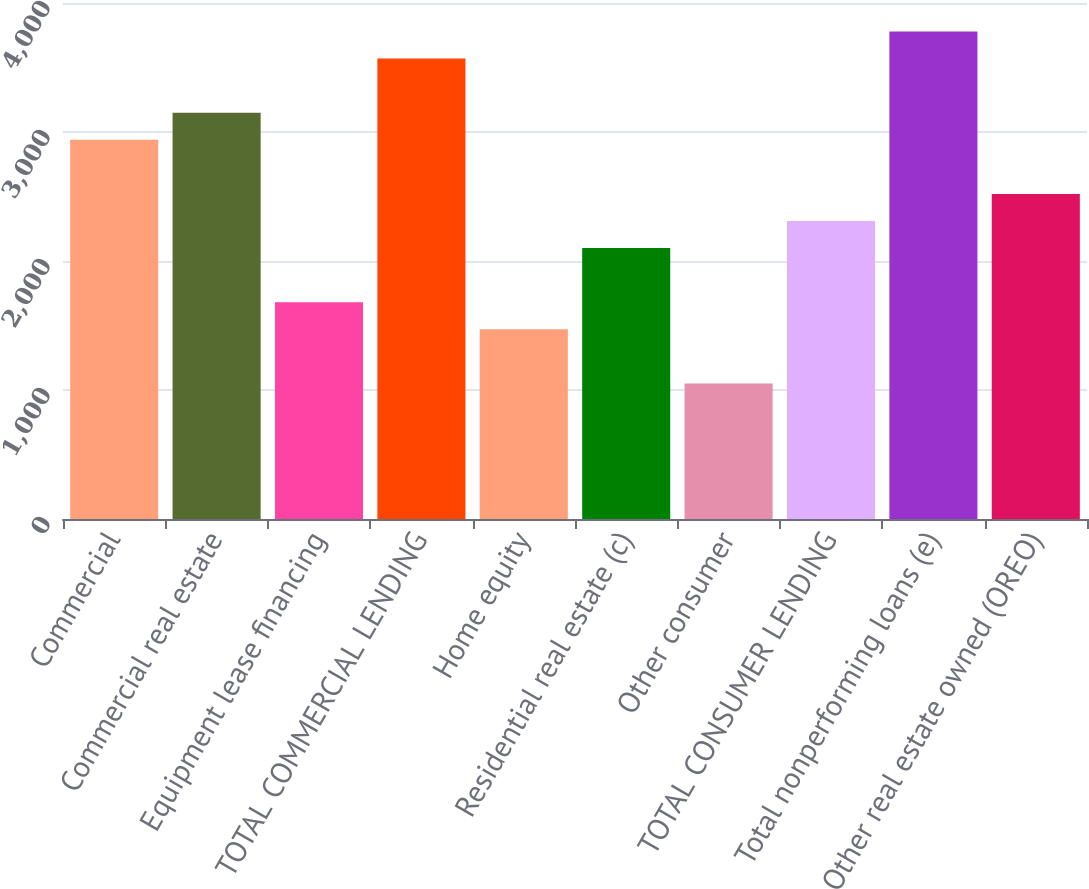Convert chart to OTSL. <chart><loc_0><loc_0><loc_500><loc_500><bar_chart><fcel>Commercial<fcel>Commercial real estate<fcel>Equipment lease financing<fcel>TOTAL COMMERCIAL LENDING<fcel>Home equity<fcel>Residential real estate (c)<fcel>Other consumer<fcel>TOTAL CONSUMER LENDING<fcel>Total nonperforming loans (e)<fcel>Other real estate owned (OREO)<nl><fcel>2939.74<fcel>3149.67<fcel>1680.16<fcel>3569.53<fcel>1470.23<fcel>2100.02<fcel>1050.37<fcel>2309.95<fcel>3779.46<fcel>2519.88<nl></chart> 